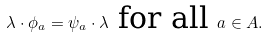<formula> <loc_0><loc_0><loc_500><loc_500>\lambda \cdot \phi _ { a } = \psi _ { a } \cdot \lambda \text { for all } a \in A .</formula> 